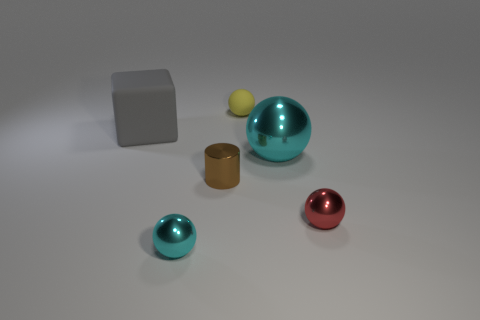What number of other things are the same color as the small rubber object?
Ensure brevity in your answer.  0. Is the number of brown metallic cylinders greater than the number of small metal things?
Your answer should be very brief. No. How big is the thing that is both behind the small brown cylinder and in front of the big matte cube?
Ensure brevity in your answer.  Large. What is the shape of the big rubber object?
Your answer should be very brief. Cube. How many red objects are the same shape as the small yellow object?
Your response must be concise. 1. Are there fewer tiny brown objects in front of the metallic cylinder than cyan objects in front of the red shiny ball?
Give a very brief answer. Yes. How many cyan spheres are behind the cyan shiny sphere that is in front of the big metal sphere?
Offer a terse response. 1. Are there any large gray things?
Provide a short and direct response. Yes. Are there any big gray blocks made of the same material as the big cyan thing?
Your answer should be compact. No. Is the number of cyan balls that are left of the block greater than the number of rubber balls behind the big cyan metallic sphere?
Give a very brief answer. No. 